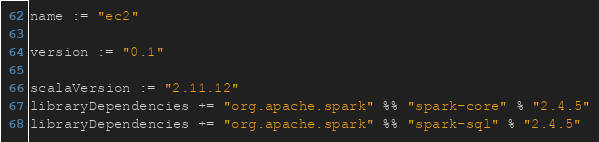Convert code to text. <code><loc_0><loc_0><loc_500><loc_500><_Scala_>name := "ec2"

version := "0.1"

scalaVersion := "2.11.12"
libraryDependencies += "org.apache.spark" %% "spark-core" % "2.4.5"
libraryDependencies += "org.apache.spark" %% "spark-sql" % "2.4.5"
</code> 